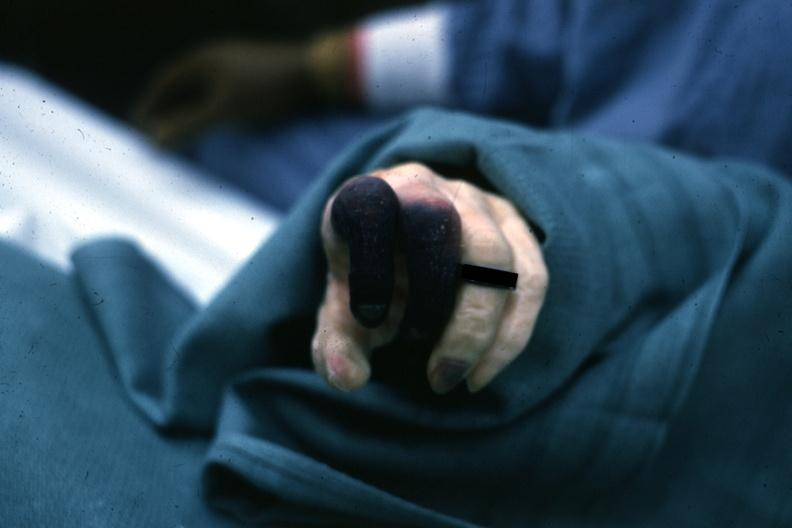what are present?
Answer the question using a single word or phrase. Extremities 